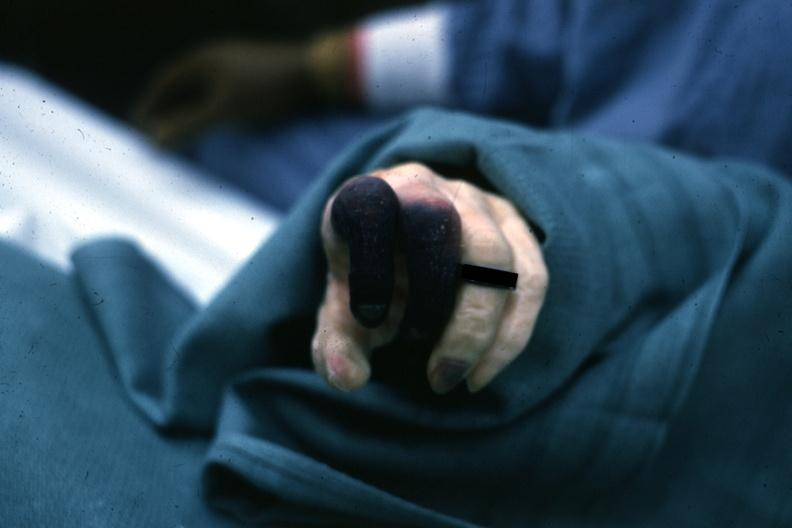what are present?
Answer the question using a single word or phrase. Extremities 